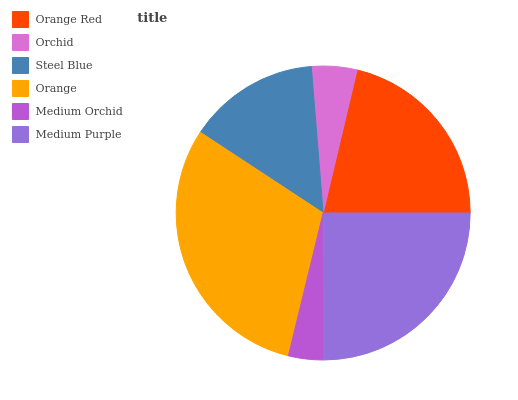Is Medium Orchid the minimum?
Answer yes or no. Yes. Is Orange the maximum?
Answer yes or no. Yes. Is Orchid the minimum?
Answer yes or no. No. Is Orchid the maximum?
Answer yes or no. No. Is Orange Red greater than Orchid?
Answer yes or no. Yes. Is Orchid less than Orange Red?
Answer yes or no. Yes. Is Orchid greater than Orange Red?
Answer yes or no. No. Is Orange Red less than Orchid?
Answer yes or no. No. Is Orange Red the high median?
Answer yes or no. Yes. Is Steel Blue the low median?
Answer yes or no. Yes. Is Orchid the high median?
Answer yes or no. No. Is Orange Red the low median?
Answer yes or no. No. 